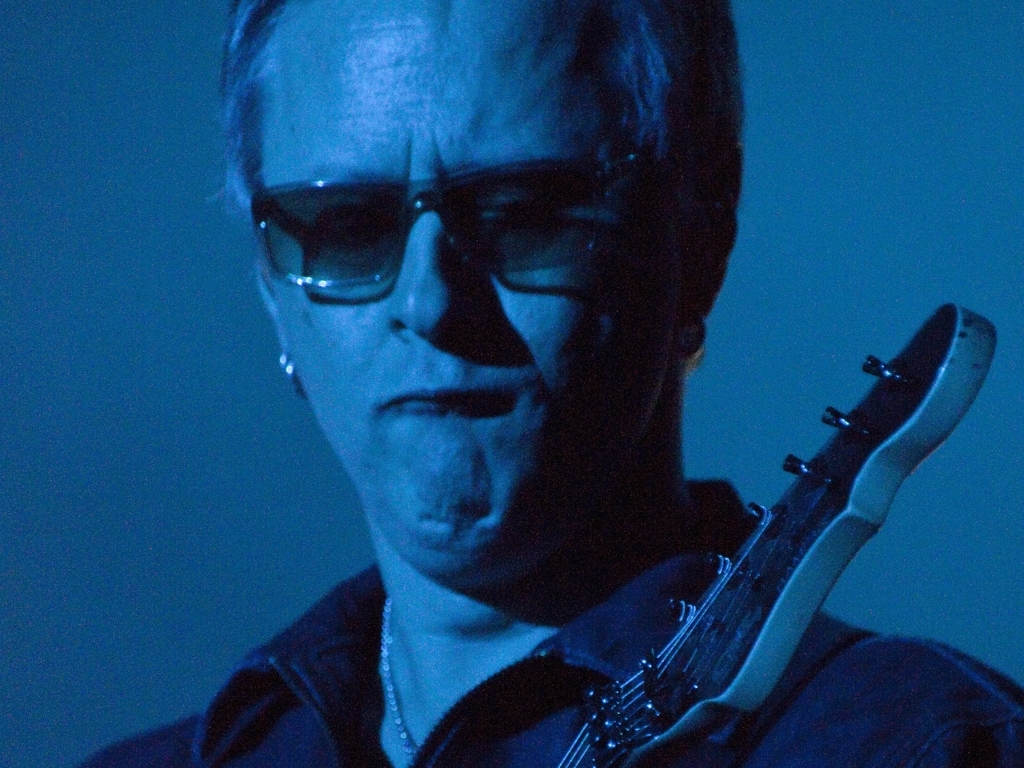What emotion does the lighting in the image evoke? The blue and dim lighting in the image evokes a sense of melancholy and intensity. It suggests a serious or reflective mood, often used in settings to invoke mystery or depth. 